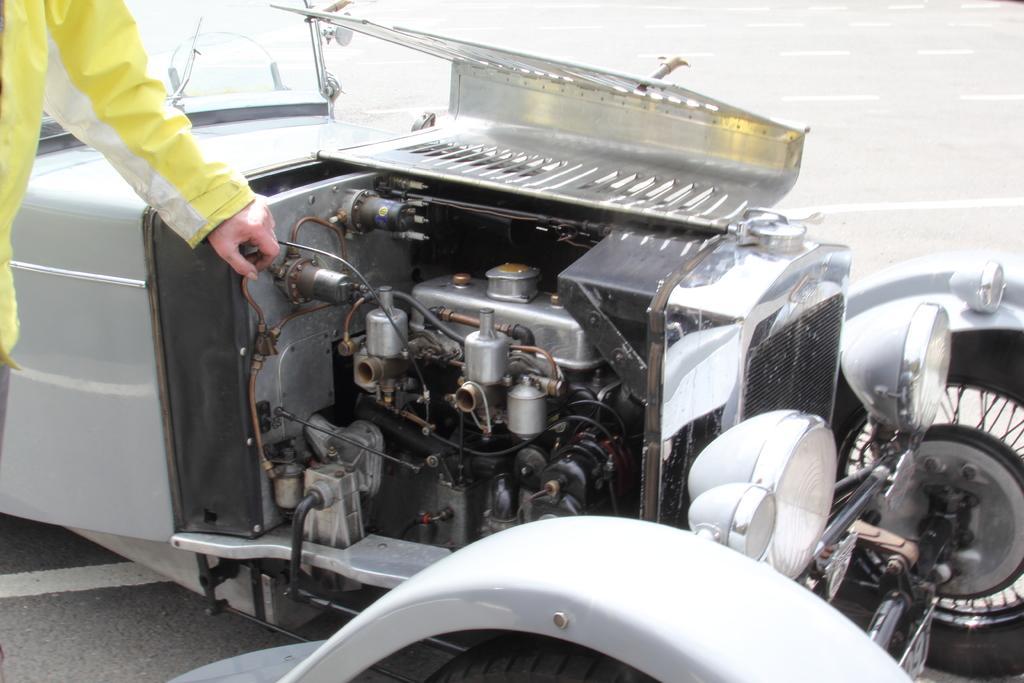In one or two sentences, can you explain what this image depicts? In this image, we can see the engine part of the vehicle. This vehicle is placed on the road. Left side of the image, we can see a human hand. Here we can see few white lines on the road. 